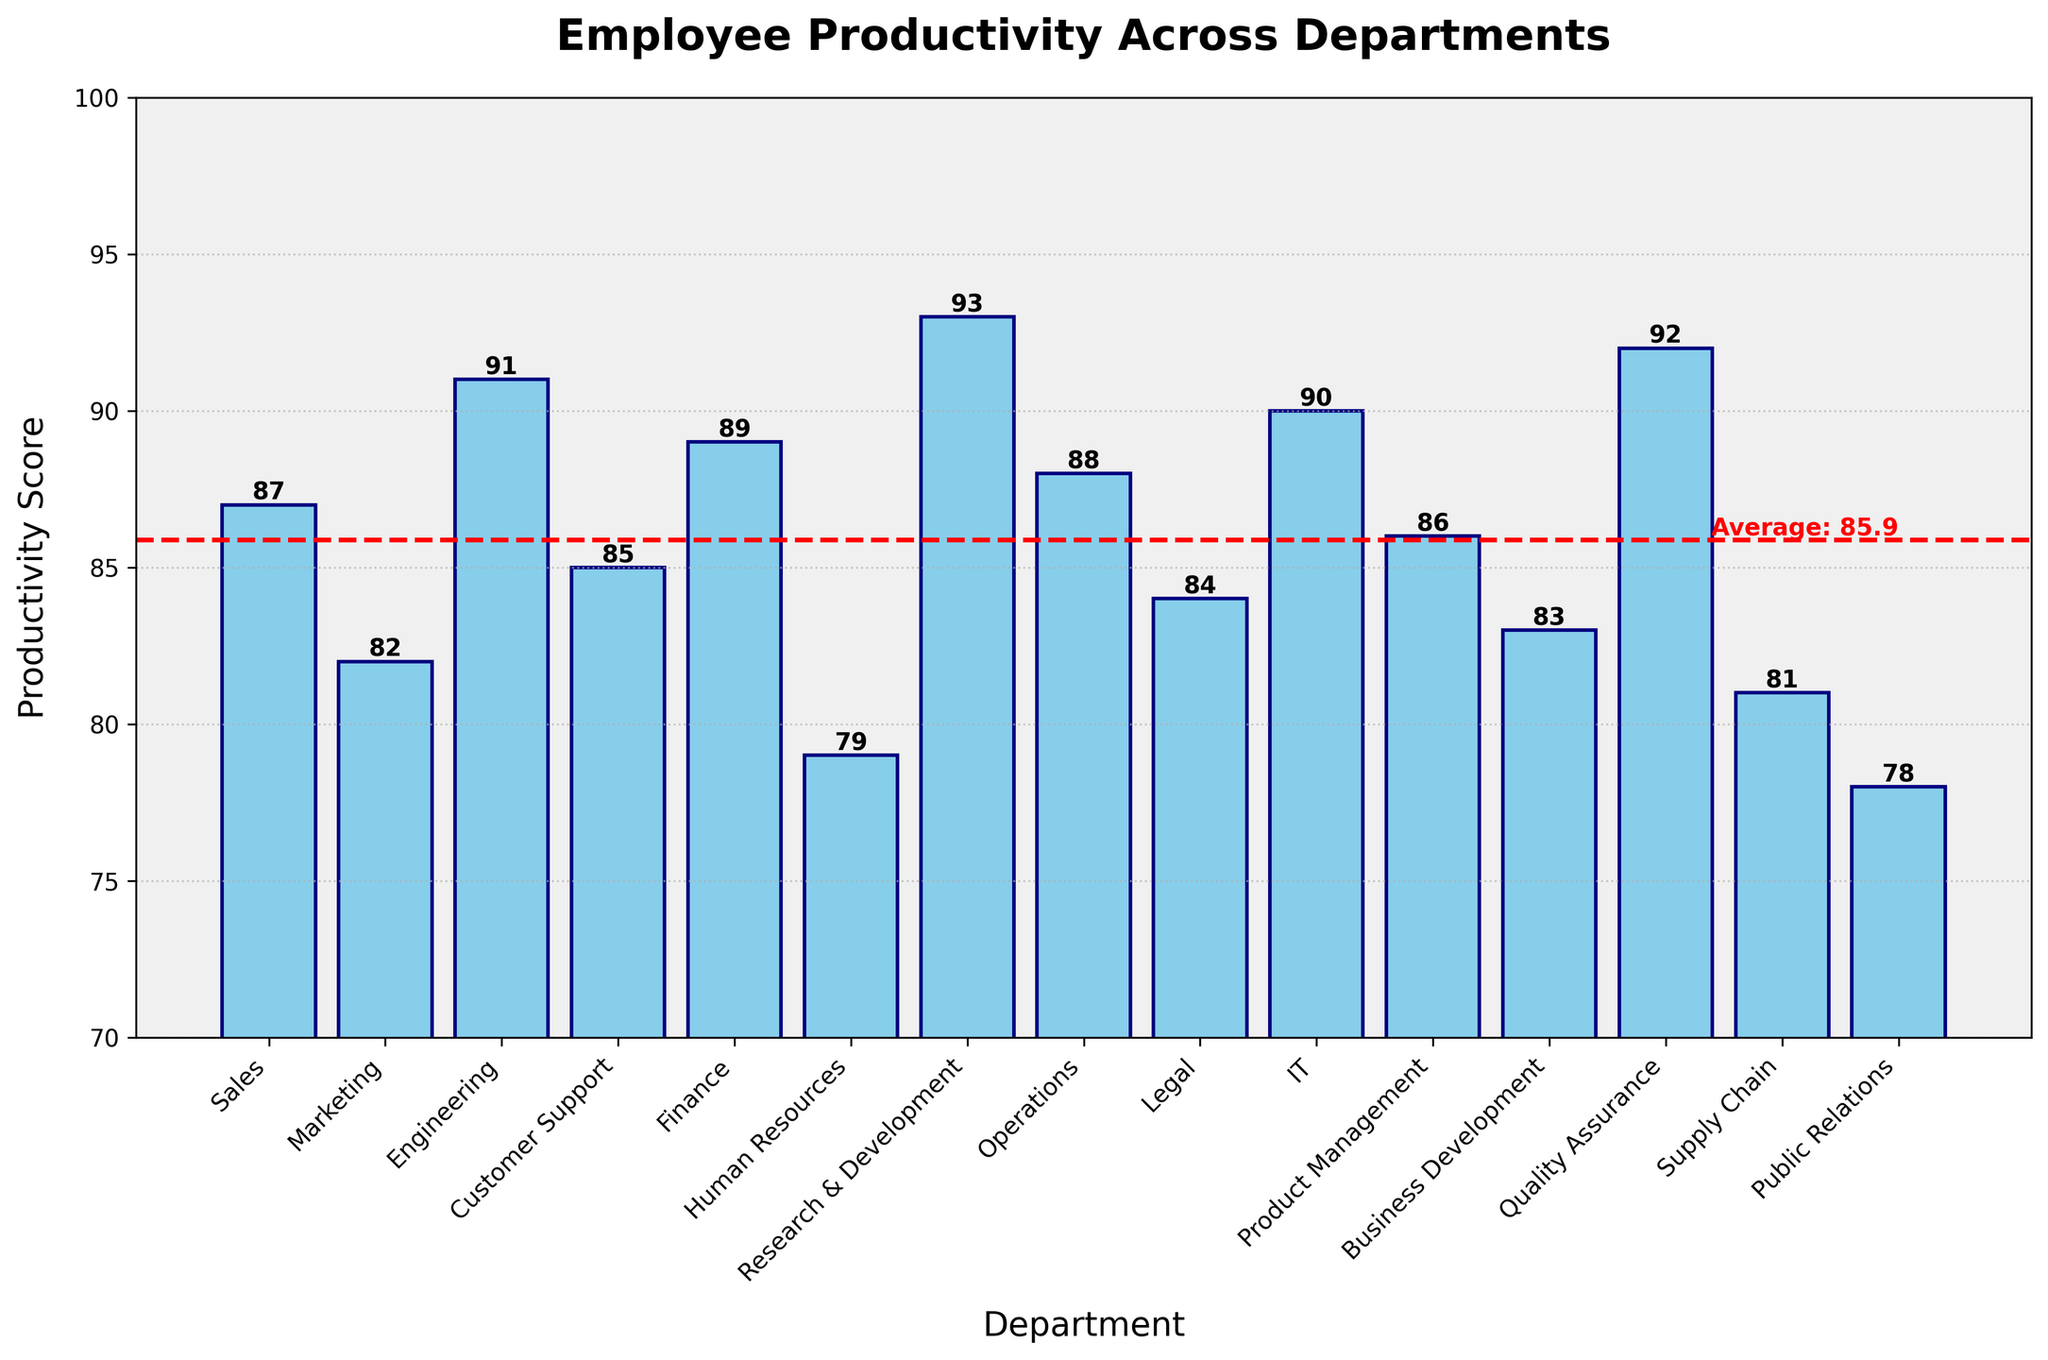Which department has the highest productivity score? The highest bar represents the highest score. Research & Development's bar is the tallest, with a score of 93.
Answer: Research & Development Which department has the lowest productivity score? The shortest bar represents the lowest score. Public Relations' bar is the shortest, with a score of 78.
Answer: Public Relations How does the productivity score of Sales compare with Marketing? Look at the height of the bars for Sales and Marketing. Sales has a score of 87, while Marketing has a score of 82.
Answer: Sales is higher How many departments have a productivity score above the average? Find the departments with scores above the red average line. The red line indicates an average score of around 85.3. Departments with higher scores are Sales, Engineering, Finance, Research & Development, Operations, IT, Product Management, and Quality Assurance.
Answer: 8 What's the difference between the highest and lowest productivity scores? Subtract the lowest score from the highest score. The highest score is 93 (Research & Development), and the lowest is 78 (Public Relations). 93 - 78 = 15.
Answer: 15 Which departments have productivity scores within one point of the average? Identify the departments with productivity scores between 84.3 and 86.3 (average ± 1). Customer Support (85), Legal (84), and Product Management (86) fall within this range.
Answer: Customer Support, Legal, Product Management How much higher is the IT department's score than the Human Resources department's score? Subtract Human Resources' score from IT's score. IT has a score of 90, and Human Resources has a score of 79. 90 - 79 = 11.
Answer: 11 What is the median productivity score among the departments? List all scores in order (78, 79, 81, 82, 83, 84, 85, 86, 87, 88, 89, 90, 91, 92, 93). The median is the value in the middle, which is 86.
Answer: 86 Which two departments have the closest productivity scores? Identify the smallest difference between adjacent scores. Marketing (82) and Supply Chain (81) have a difference of 1.
Answer: Marketing and Supply Chain 